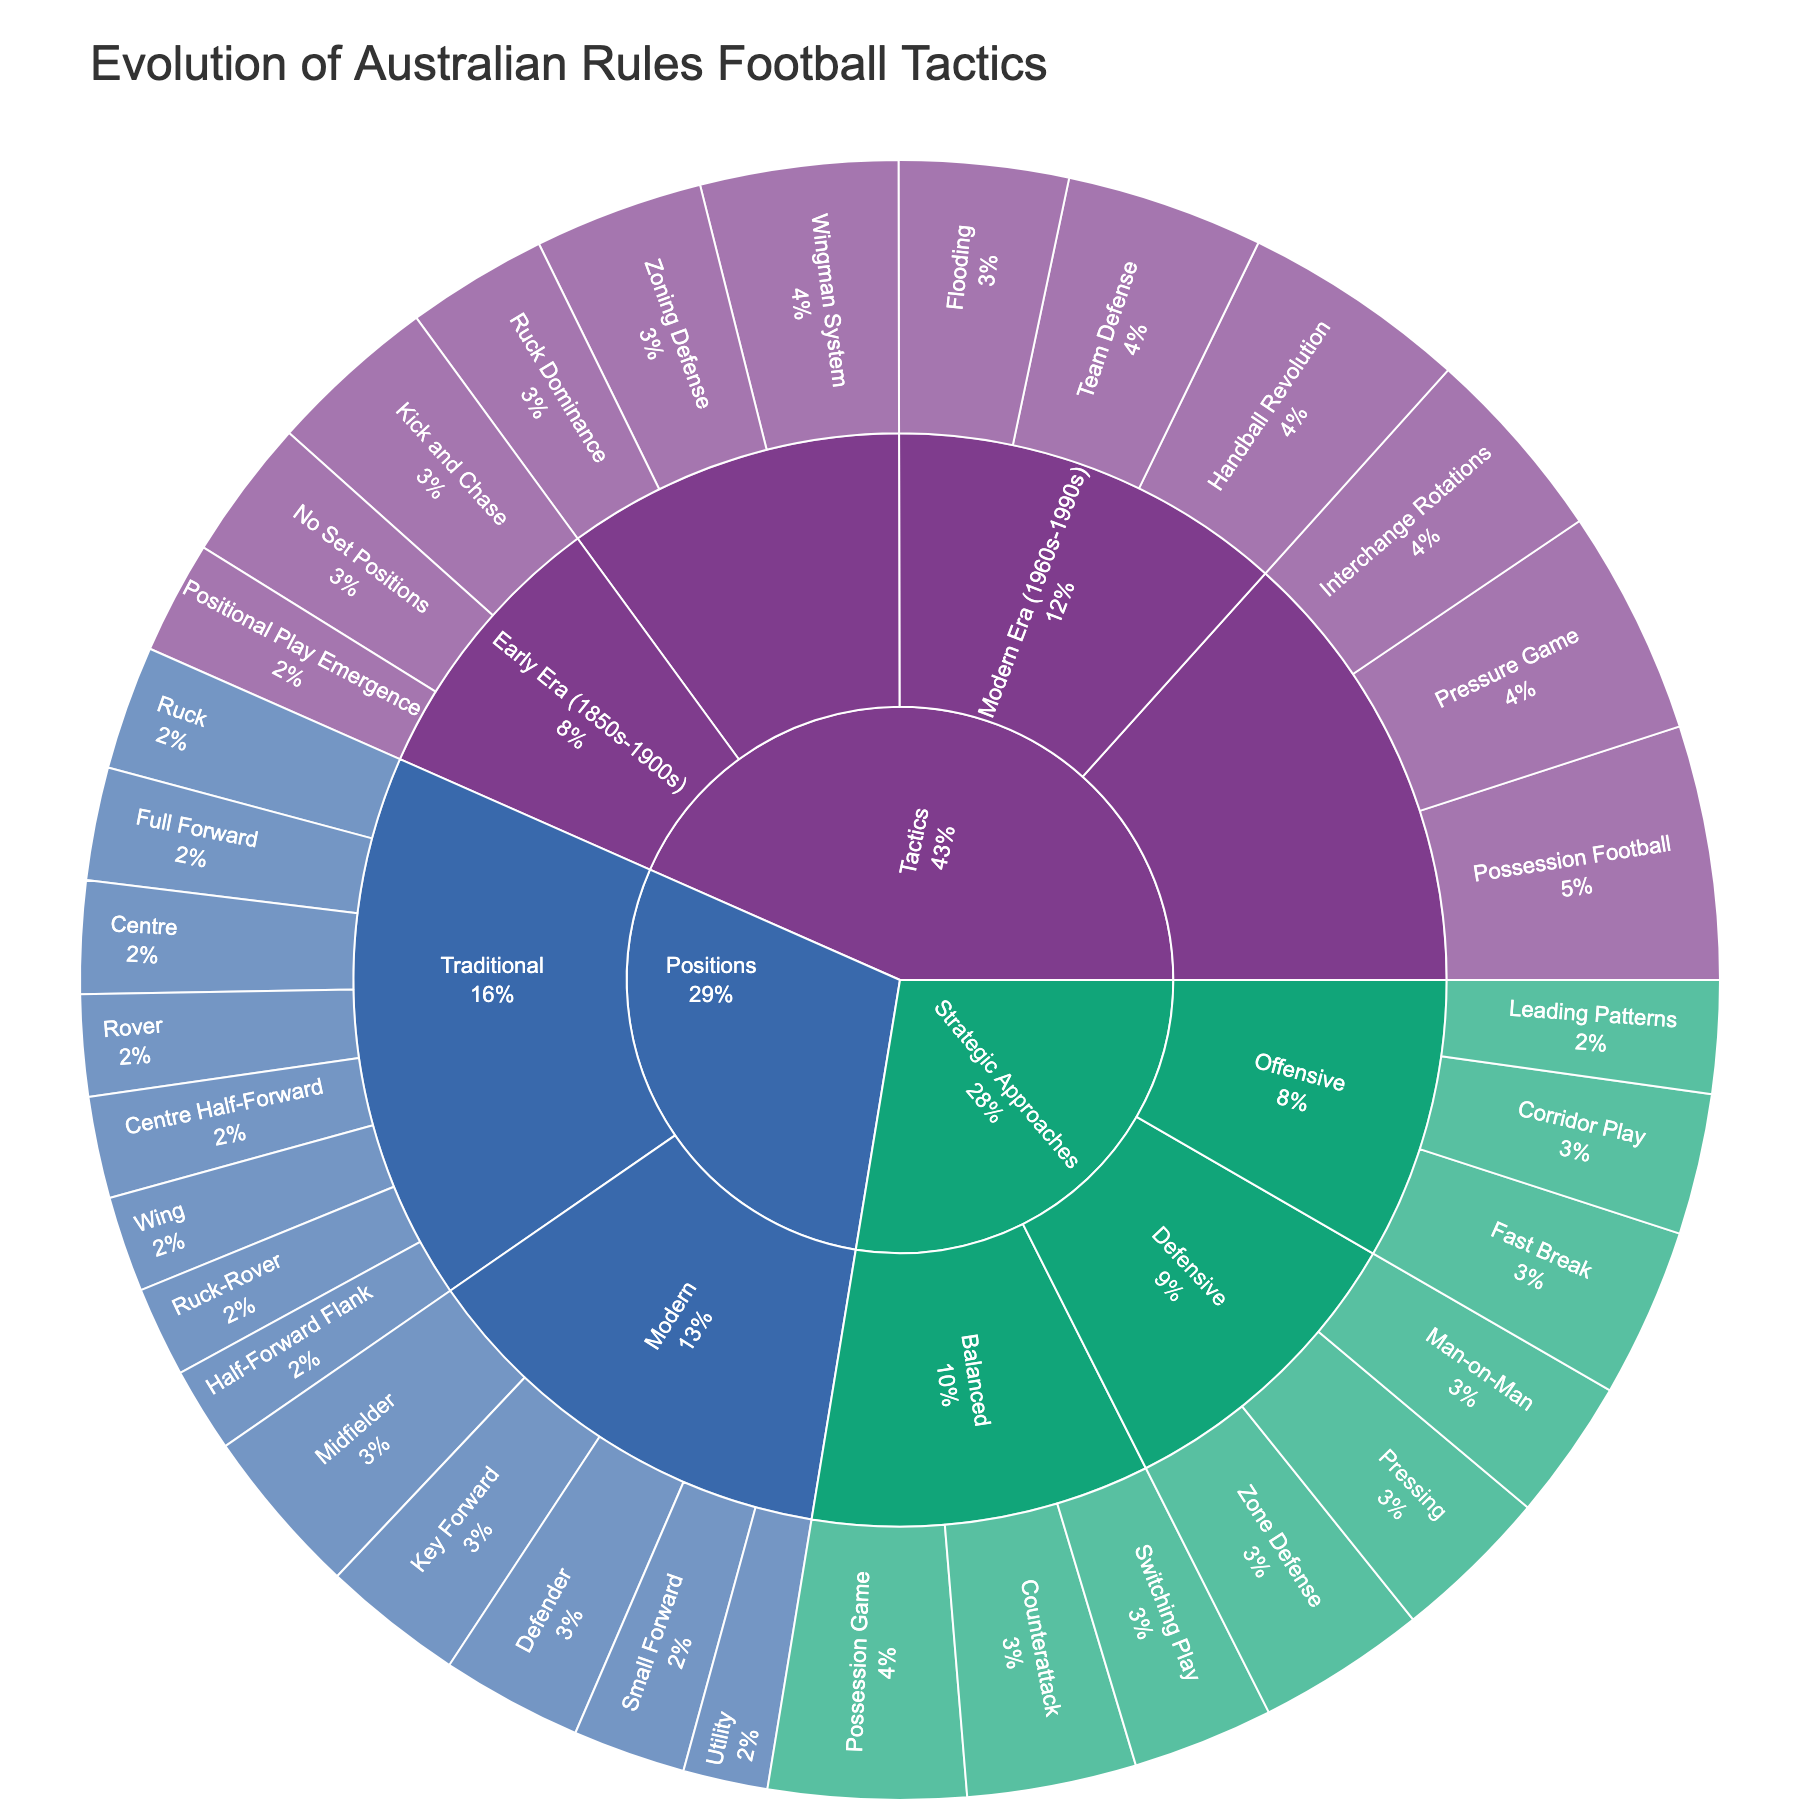what is the title of the plot? The title is usually placed at the top of the plot and provides a summary of what the plot represents. In this case, the title is "Evolution of Australian Rules Football Tactics", which tells us that the plot visualizes the development and changes in tactics over time.
Answer: Evolution of Australian Rules Football Tactics Which category has the highest total value in the plot? To determine the category with the highest total value, sum the values of all subcategories within each main category. The values are: Tactics (25 + 30 + 20 + 35 + 30 + 25 + 40 + 35 + 30 + 45 + 40 + 35 = 390), Positions (20 + 18 + 15 + 17 + 20 + 22 + 18 + 16 + 25 + 20 + 30 + 25 + 15 = 261), Strategic Approaches (30 + 25 + 20 + 25 + 30 + 28 + 35 + 30 + 25 = 248). Therefore, the Tactics category has the highest total value.
Answer: Tactics Which era within the Tactics category has the largest proportion? Within the Tactics category, compare the subcategory values: Early Era (25 + 30 + 20 = 75), Consolidation Era (35 + 30 + 25 = 90), Modern Era (40 + 35 + 30 = 105), Contemporary Era (45 + 40 + 35 = 120). The Contemporary Era has the largest total value and hence the largest proportion.
Answer: Contemporary Era Compare the values of Kick and Chase vs Possession Football in the Tactics category. Which is higher? Within the Tactics category, locate the Kick and Chase value (30) and the Possession Football value (45). Since 45 is greater than 30, Possession Football has a higher value.
Answer: Possession Football What is the sum of values for the Traditional positions in the Positions category? Sum up the values of all Traditional positions in the Positions category: Full Forward (20) + Centre Half-Forward (18) + Half-Forward Flank (15) + Wing (17) + Centre (20) + Ruck (22) + Rover (18) + Ruck-Rover (16). The sum is 20 + 18 + 15 + 17 + 20 + 22 + 18 + 16 = 146.
Answer: 146 Which Offensive strategic approach has the smallest value? Within the Strategic Approaches category, locate the Offensive subcategory and compare its elements: Fast Break (30), Corridor Play (25), Leading Patterns (20). Leading Patterns has the smallest value among them.
Answer: Leading Patterns What is the percentage of Interchange Rotations relative to the total value of the Contemporary Era subcategory? First, obtain the total value of the Contemporary Era subcategory: 45 (Possession Football) + 40 (Pressure Game) + 35 (Interchange Rotations) = 120. Then, calculate the percentage of Interchange Rotations: (35/120) * 100 = 29.2%.
Answer: 29.2% Which Defensive strategic approach has a higher value: Man-on-Man or Pressing? Compare the values within the Defensive subcategory in Strategic Approaches: Man-on-Man (25) and Pressing (28). Since 28 is greater than 25, Pressing has a higher value.
Answer: Pressing 